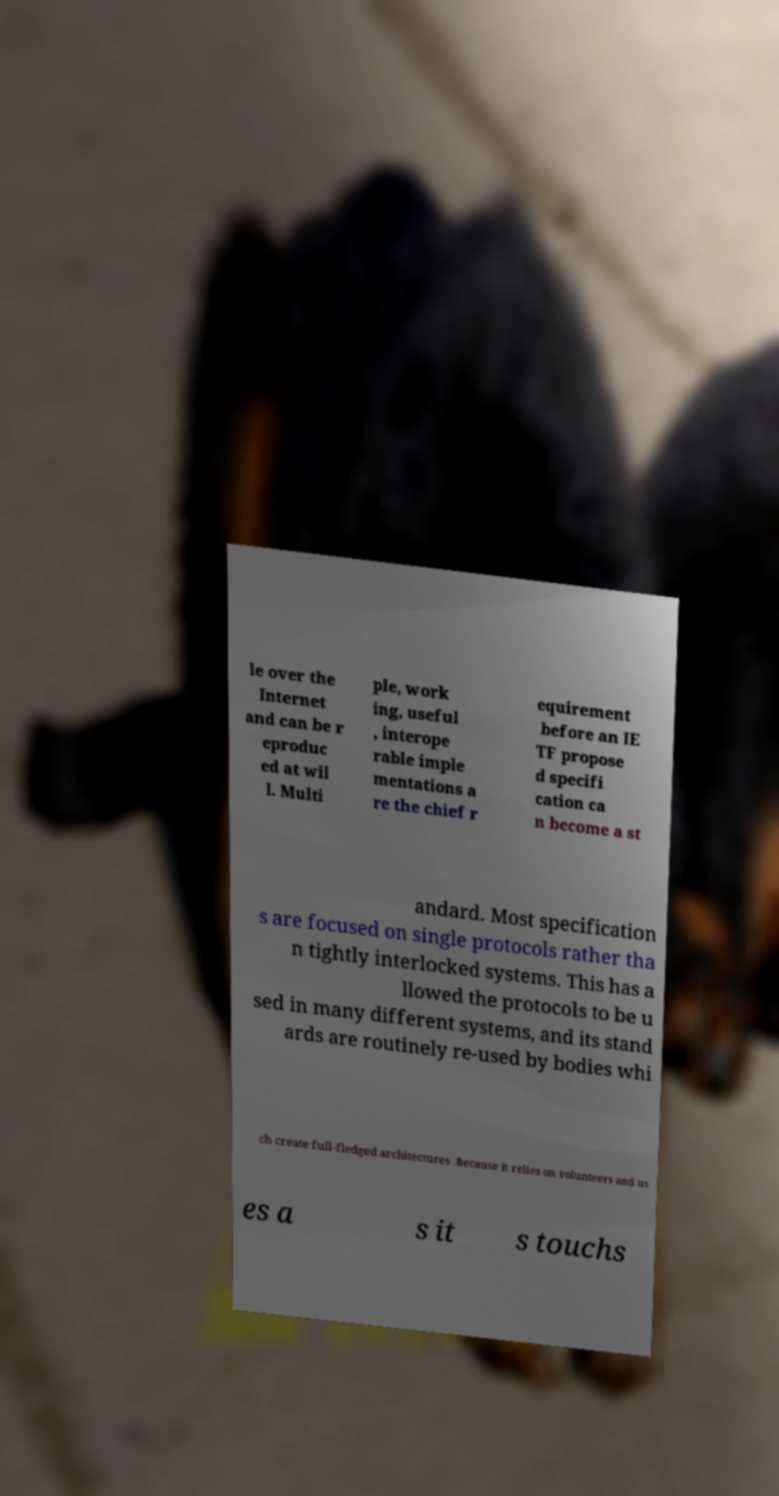What messages or text are displayed in this image? I need them in a readable, typed format. le over the Internet and can be r eproduc ed at wil l. Multi ple, work ing, useful , interope rable imple mentations a re the chief r equirement before an IE TF propose d specifi cation ca n become a st andard. Most specification s are focused on single protocols rather tha n tightly interlocked systems. This has a llowed the protocols to be u sed in many different systems, and its stand ards are routinely re-used by bodies whi ch create full-fledged architectures .Because it relies on volunteers and us es a s it s touchs 